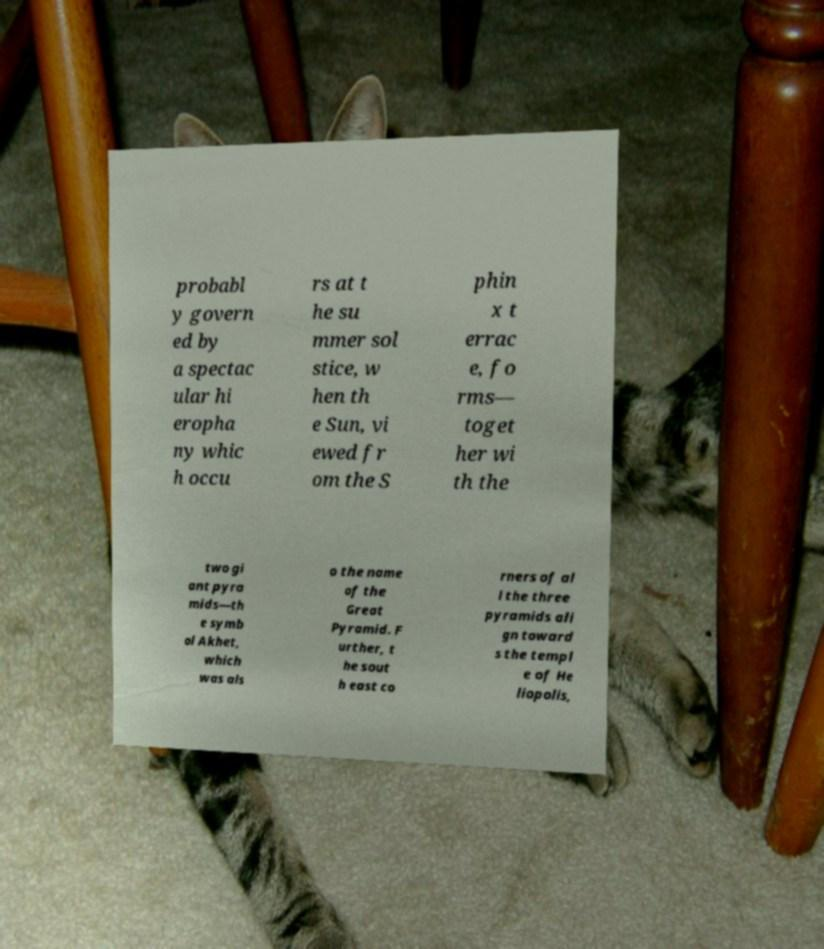Could you assist in decoding the text presented in this image and type it out clearly? probabl y govern ed by a spectac ular hi eropha ny whic h occu rs at t he su mmer sol stice, w hen th e Sun, vi ewed fr om the S phin x t errac e, fo rms— toget her wi th the two gi ant pyra mids—th e symb ol Akhet, which was als o the name of the Great Pyramid. F urther, t he sout h east co rners of al l the three pyramids ali gn toward s the templ e of He liopolis, 